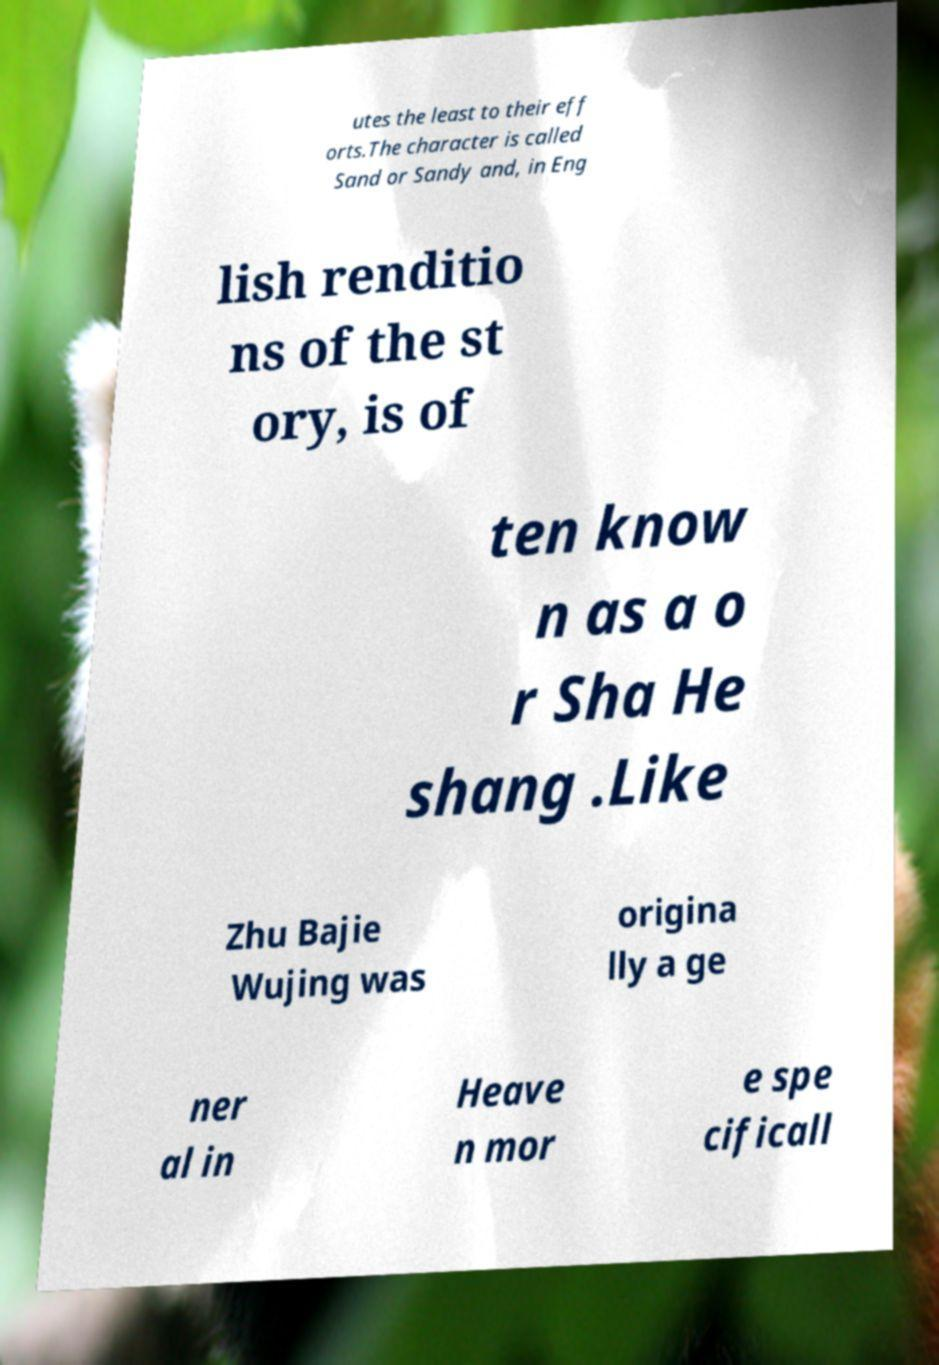There's text embedded in this image that I need extracted. Can you transcribe it verbatim? utes the least to their eff orts.The character is called Sand or Sandy and, in Eng lish renditio ns of the st ory, is of ten know n as a o r Sha He shang .Like Zhu Bajie Wujing was origina lly a ge ner al in Heave n mor e spe cificall 